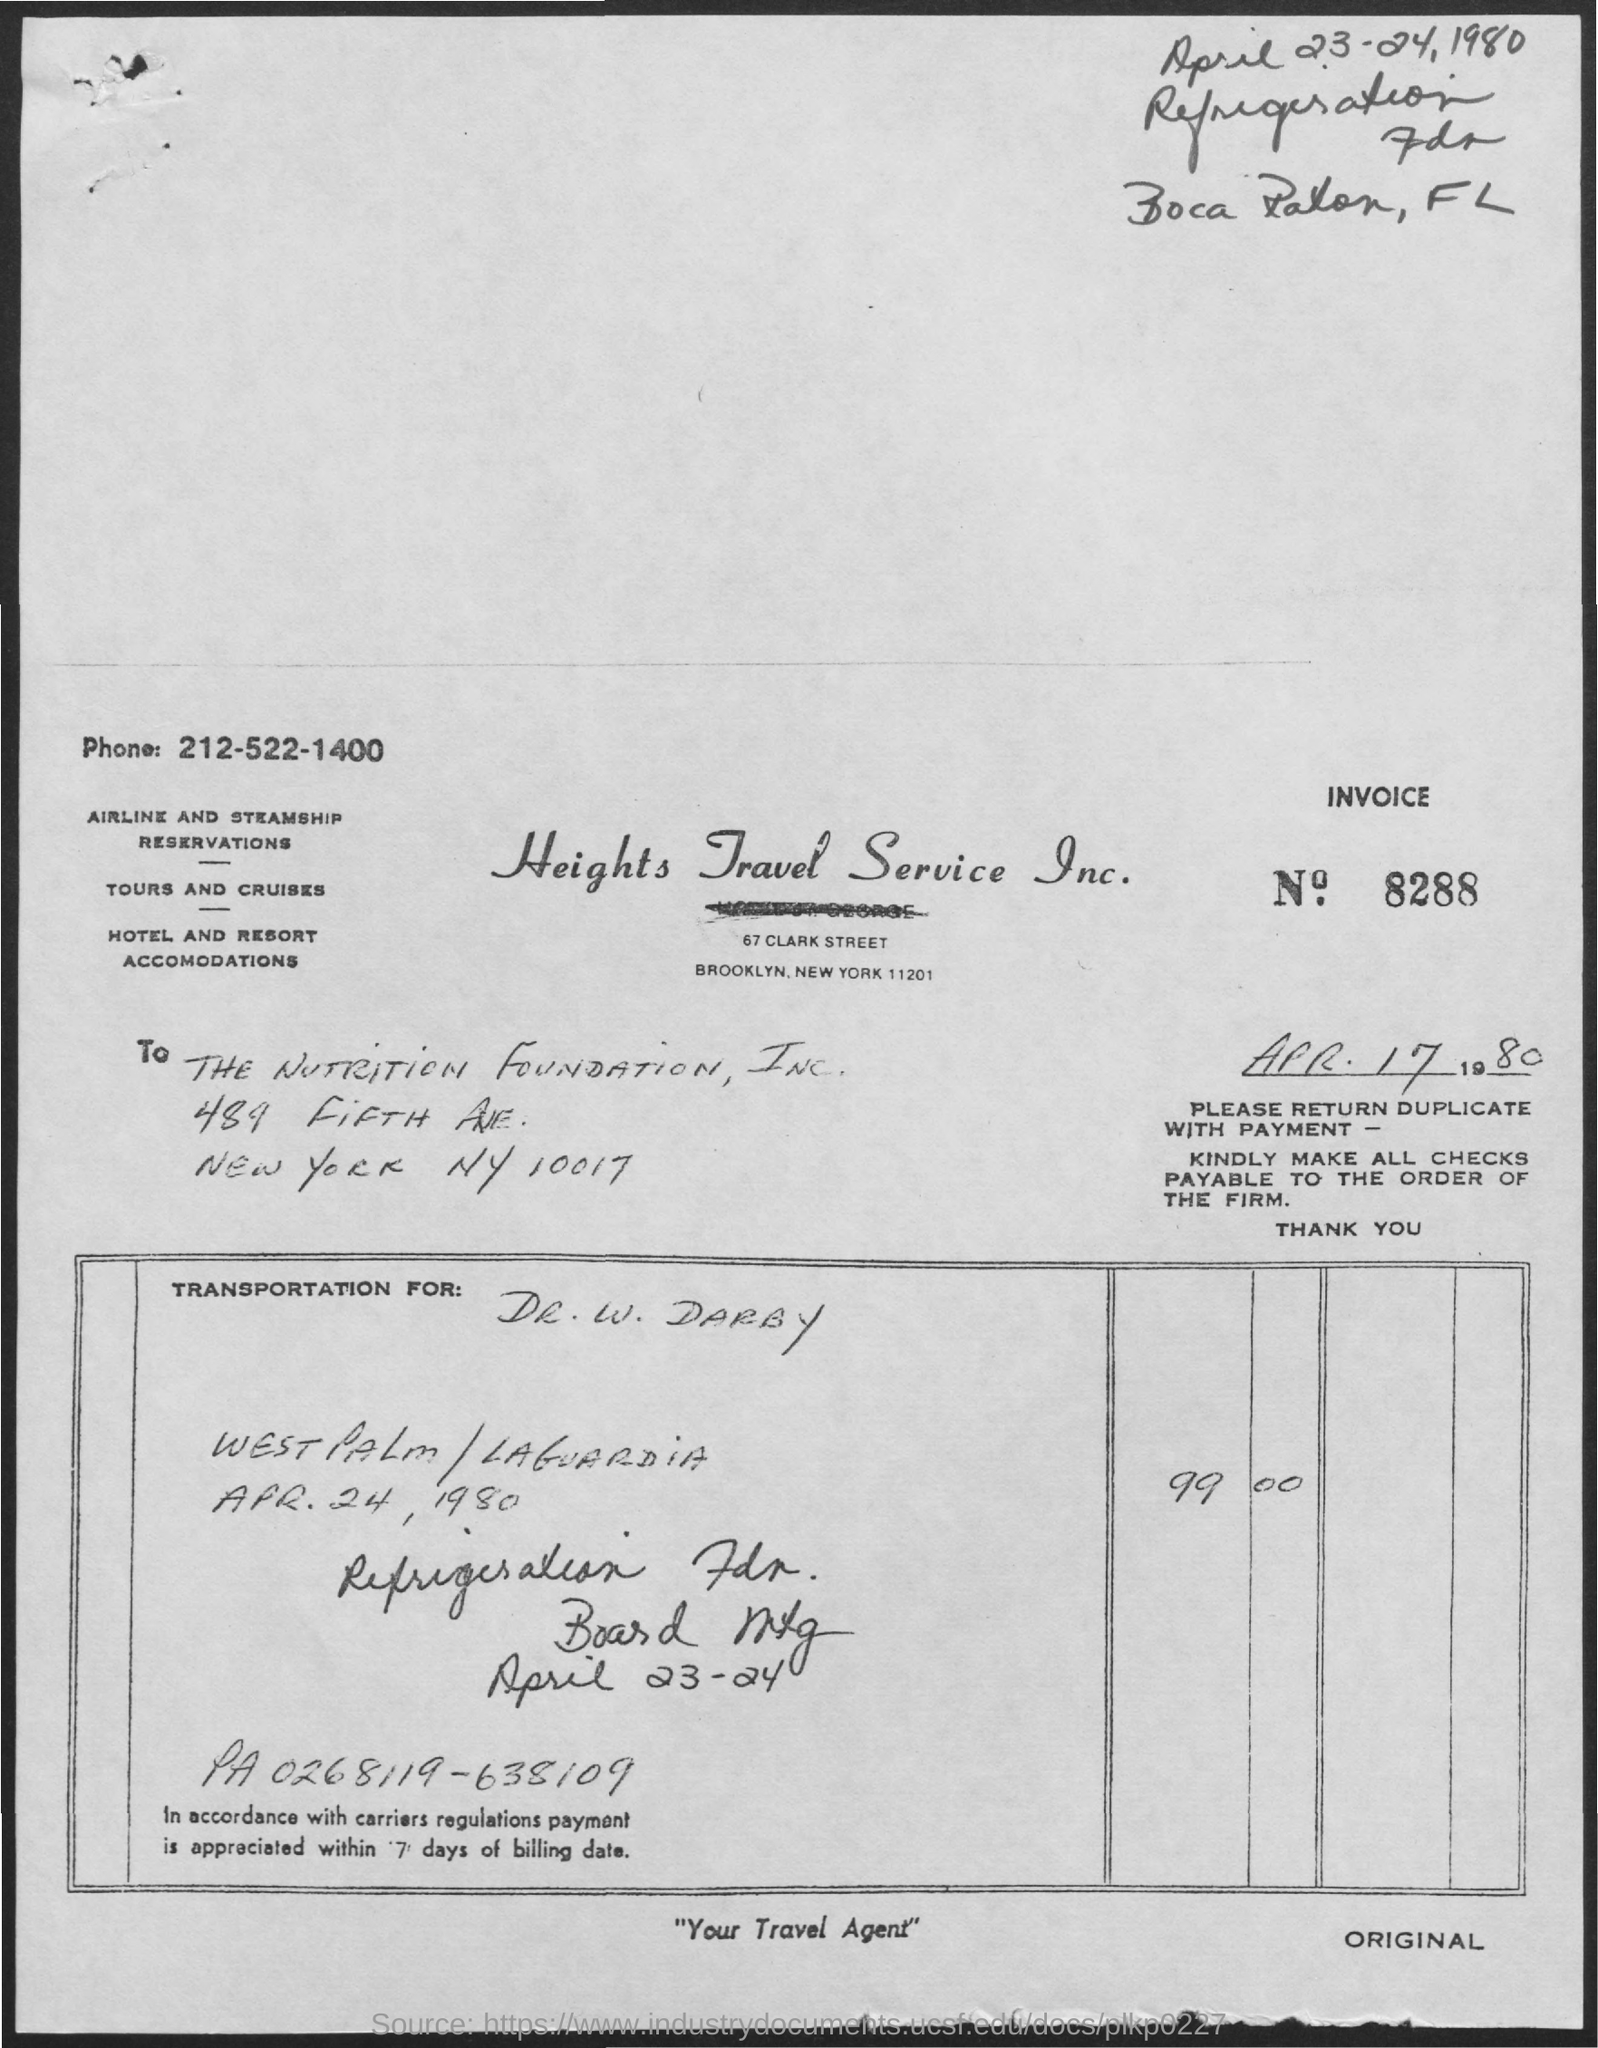What is the phone number mentioned on the invoice?
Offer a terse response. 212-522-1400. The document is addressed to whom?
Offer a very short reply. THE NUTRITION FOUNDATION, INC. Payment has to be done within how many days?
Your answer should be very brief. '7' DAYS OF BILLING DATE. 